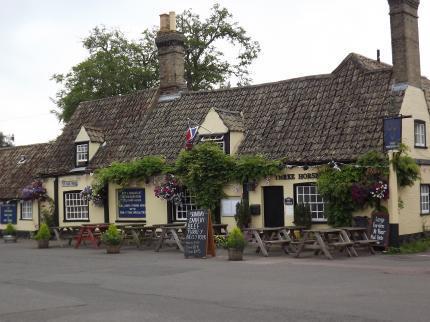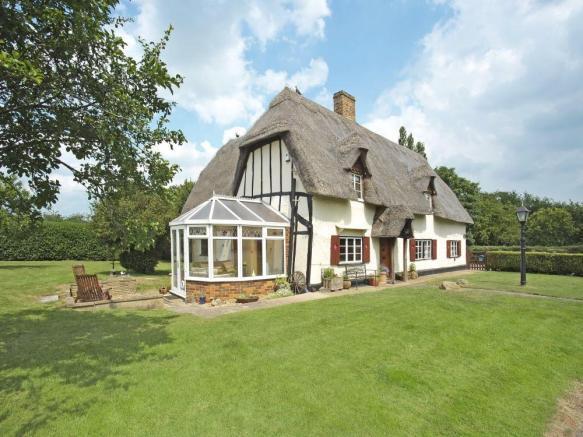The first image is the image on the left, the second image is the image on the right. For the images shown, is this caption "In the right image at least two chimneys are visible." true? Answer yes or no. No. 